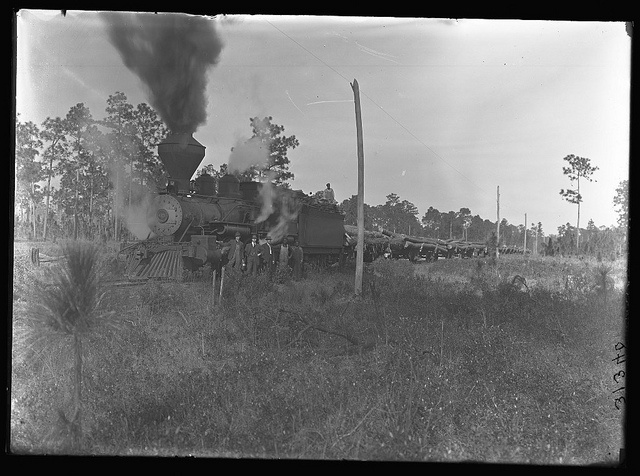Describe the objects in this image and their specific colors. I can see train in black, gray, and lightgray tones, people in gray and black tones, people in black, gray, darkgray, and lightgray tones, people in black, gray, darkgray, and lightgray tones, and people in gray and black tones in this image. 